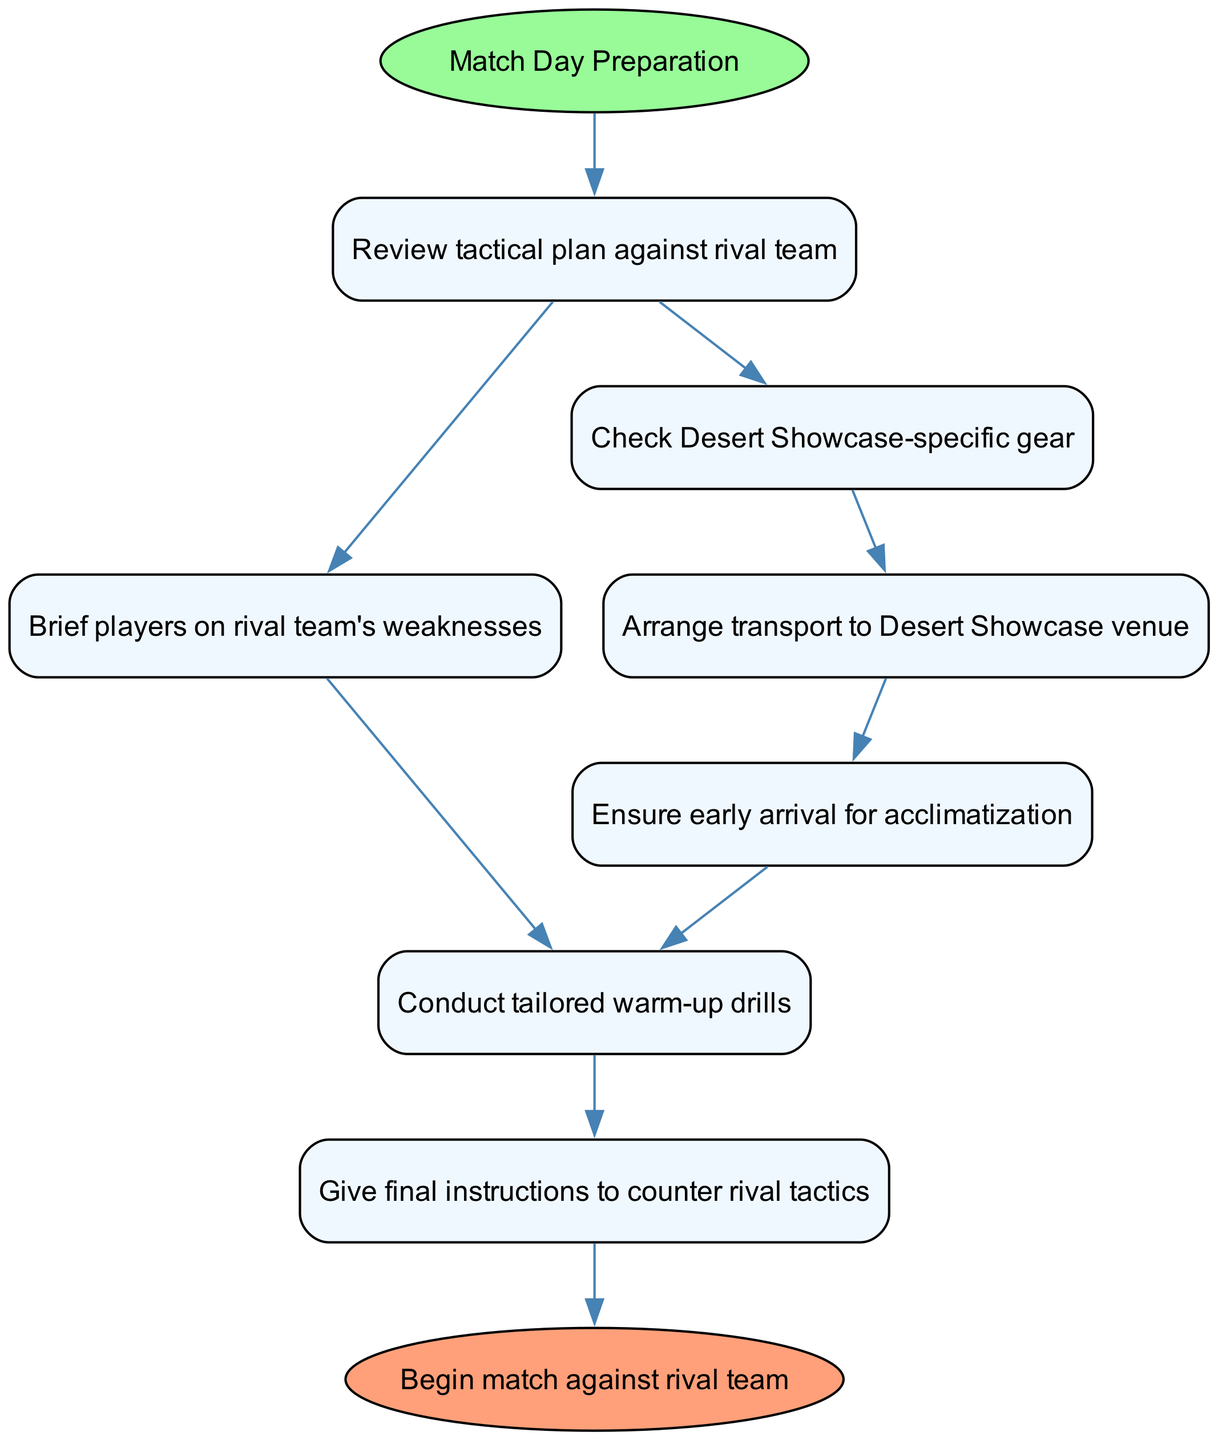What is the starting point of the flowchart? The starting point of the flowchart is labeled as "Match Day Preparation," which is represented as the initial node before all subsequent processes.
Answer: Match Day Preparation How many nodes are there in the diagram? The diagram consists of eight nodes that are part of the preparation checklist and logistics management.
Answer: Eight What are the two immediate next steps after "Review tactical plan against rival team"? The two immediate next steps after "Review tactical plan against rival team" are "Brief players on rival team's weaknesses" and "Check Desert Showcase-specific gear," according to the branching from this node.
Answer: Brief players on rival team's weaknesses, Check Desert Showcase-specific gear Which node has the final instruction before the match begins? The node labeled "Give final instructions to counter rival tactics" serves as the last step before moving to the match start, connecting directly to the "Begin match against rival team" node.
Answer: Give final instructions to counter rival tactics What is the purpose of the "Ensure early arrival for acclimatization" step? The purpose of the "Ensure early arrival for acclimatization" step is to facilitate proper adjustment before the match starts, which is essential for player performance, positioning it strategically after transport arrangements.
Answer: To facilitate proper adjustment before the match starts If the team conducts tailored warm-up drills, what is the next step they will take? After conducting tailored warm-up drills, the next step they will take is to give final instructions to counter rival tactics, following the flow from this node.
Answer: Give final instructions to counter rival tactics What is the relationship between "Check Desert Showcase-specific gear" and "Arrange transport to Desert Showcase venue"? "Check Desert Showcase-specific gear" directly leads to "Arrange transport to Desert Showcase venue," indicating that the equipment check is a prerequisite before managing logistics for transportation.
Answer: Directly leads to What color represents the final node in the flowchart? The final node "Begin match against rival team" is represented in the flowchart with a light salmon color, distinguishing it as the endpoint of the preparation process.
Answer: Light salmon What sequence of nodes follows after "Conduct tailored warm-up drills"? The sequence of nodes that follows "Conduct tailored warm-up drills" consists of "Give final instructions to counter rival tactics," thus indicating critical final preparations before the match.
Answer: Give final instructions to counter rival tactics 